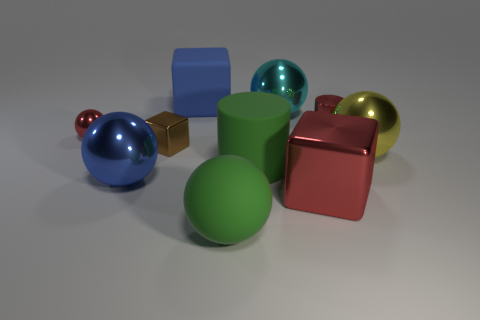Subtract all cyan balls. How many balls are left? 4 Subtract all big yellow balls. How many balls are left? 4 Subtract 1 balls. How many balls are left? 4 Subtract all brown balls. Subtract all purple cylinders. How many balls are left? 5 Subtract all cylinders. How many objects are left? 8 Subtract all big red blocks. Subtract all cyan shiny things. How many objects are left? 8 Add 1 cyan balls. How many cyan balls are left? 2 Add 7 tiny red metallic cubes. How many tiny red metallic cubes exist? 7 Subtract 1 blue cubes. How many objects are left? 9 